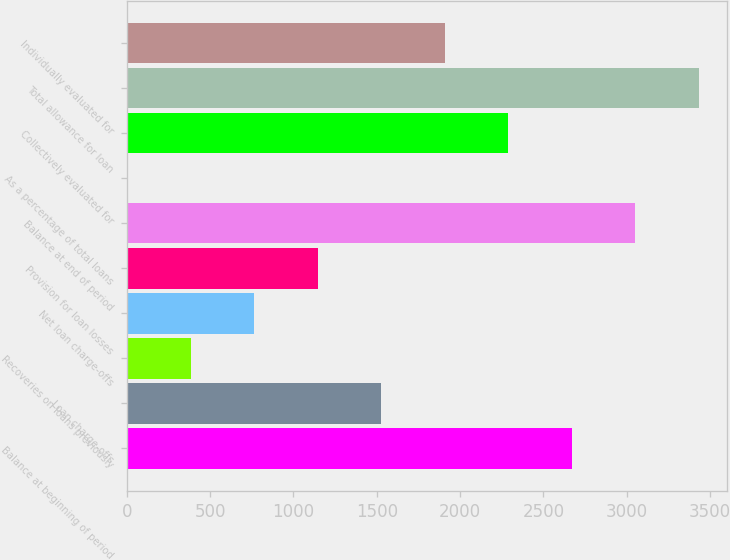Convert chart to OTSL. <chart><loc_0><loc_0><loc_500><loc_500><bar_chart><fcel>Balance at beginning of period<fcel>Loan charge-offs<fcel>Recoveries on loans previously<fcel>Net loan charge-offs<fcel>Provision for loan losses<fcel>Balance at end of period<fcel>As a percentage of total loans<fcel>Collectively evaluated for<fcel>Total allowance for loan<fcel>Individually evaluated for<nl><fcel>2668.34<fcel>1525.64<fcel>382.94<fcel>763.84<fcel>1144.74<fcel>3049.24<fcel>2.04<fcel>2287.44<fcel>3430.14<fcel>1906.54<nl></chart> 